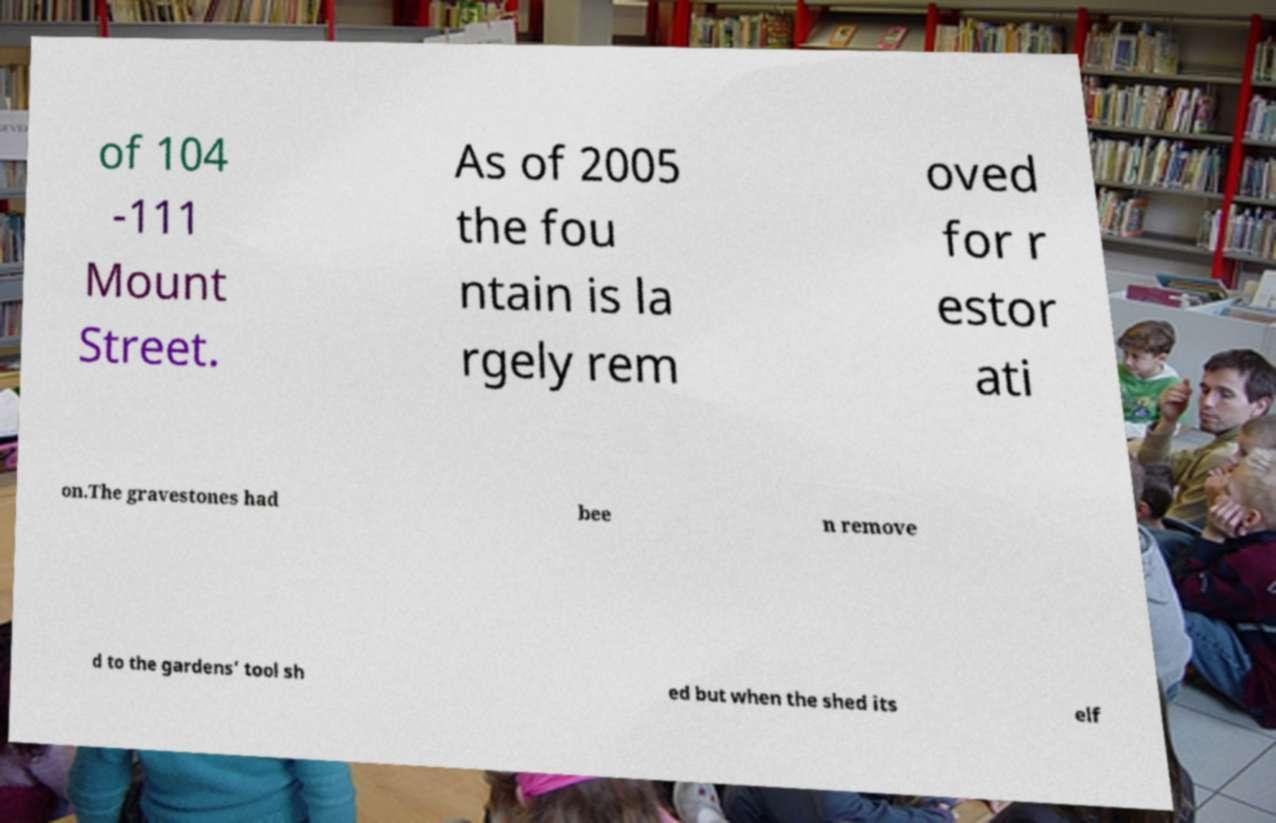For documentation purposes, I need the text within this image transcribed. Could you provide that? of 104 -111 Mount Street. As of 2005 the fou ntain is la rgely rem oved for r estor ati on.The gravestones had bee n remove d to the gardens' tool sh ed but when the shed its elf 